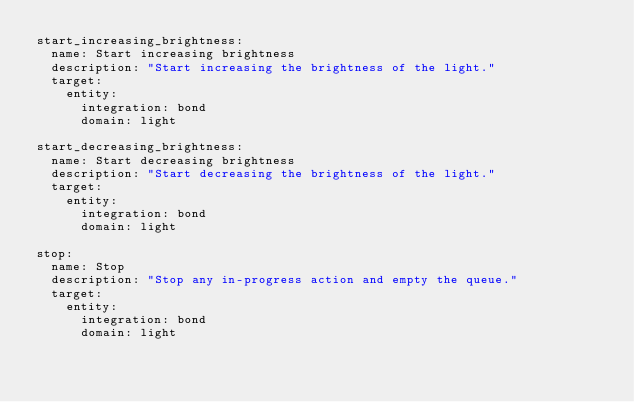Convert code to text. <code><loc_0><loc_0><loc_500><loc_500><_YAML_>start_increasing_brightness:
  name: Start increasing brightness
  description: "Start increasing the brightness of the light."
  target:
    entity:
      integration: bond
      domain: light

start_decreasing_brightness:
  name: Start decreasing brightness
  description: "Start decreasing the brightness of the light."
  target:
    entity:
      integration: bond
      domain: light

stop:
  name: Stop
  description: "Stop any in-progress action and empty the queue."
  target:
    entity:
      integration: bond
      domain: light
</code> 